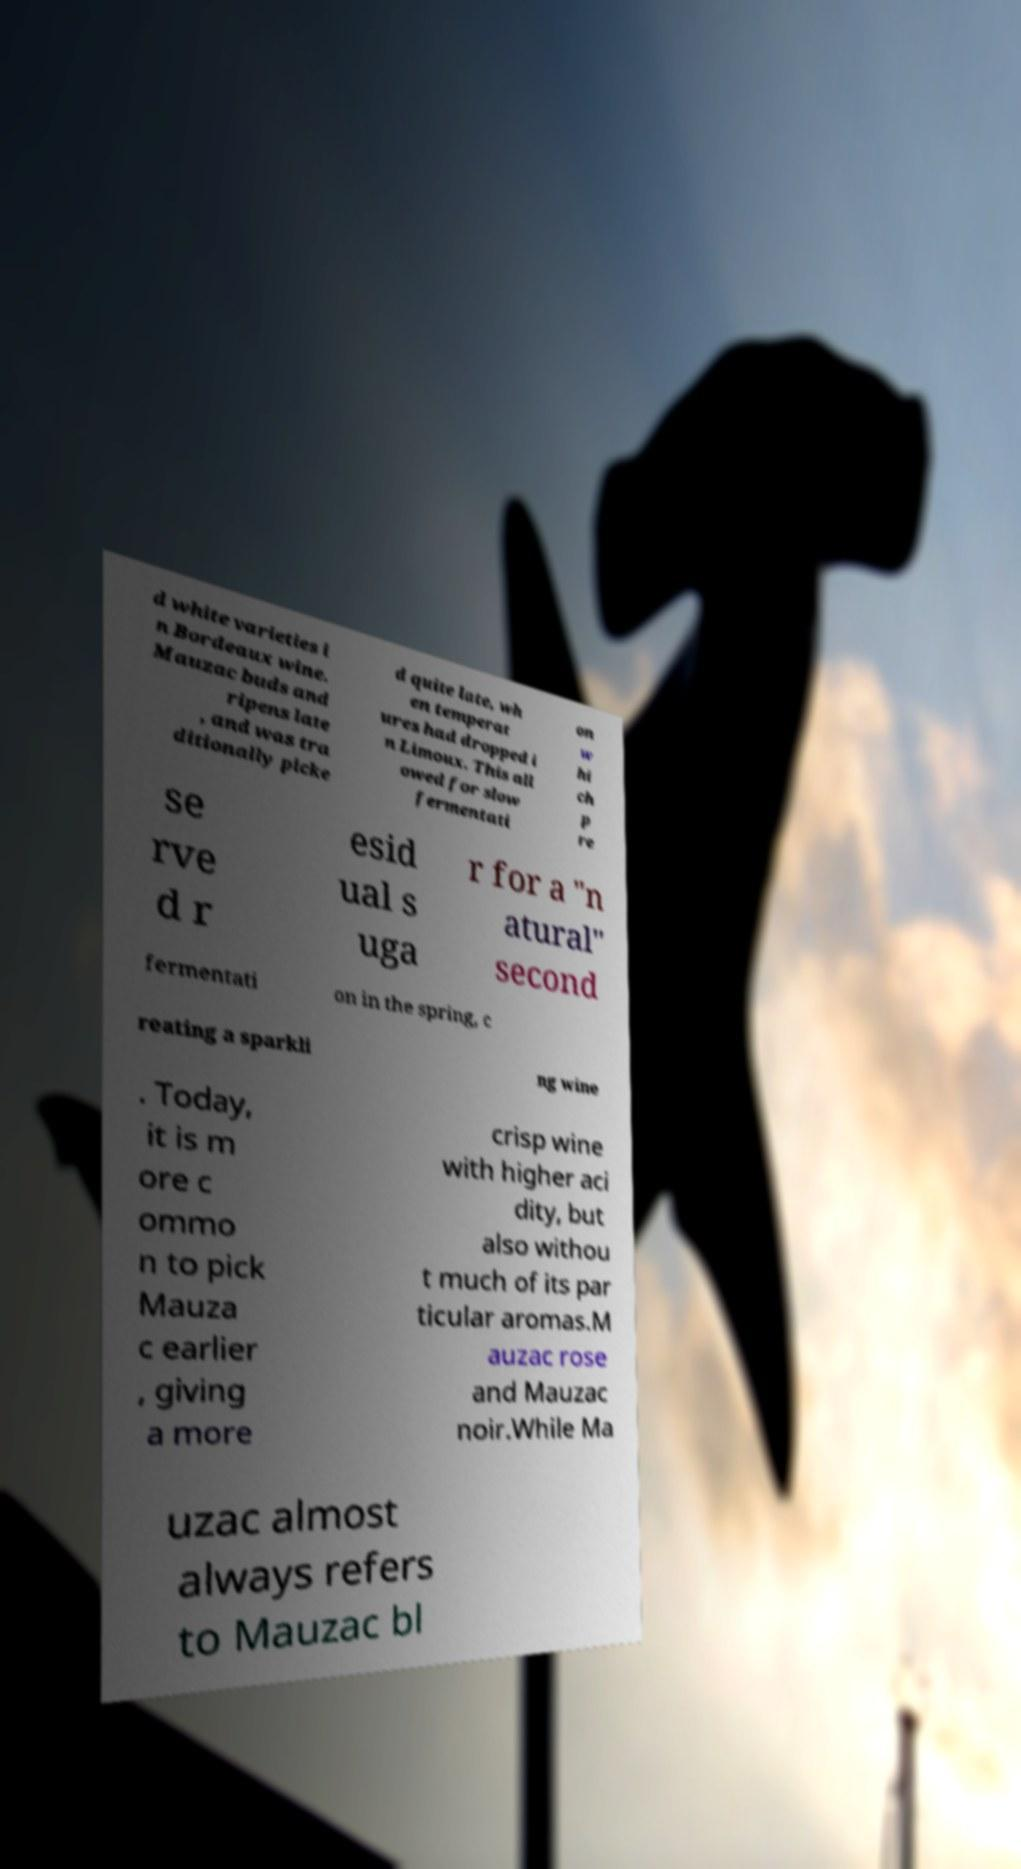What messages or text are displayed in this image? I need them in a readable, typed format. d white varieties i n Bordeaux wine. Mauzac buds and ripens late , and was tra ditionally picke d quite late, wh en temperat ures had dropped i n Limoux. This all owed for slow fermentati on w hi ch p re se rve d r esid ual s uga r for a "n atural" second fermentati on in the spring, c reating a sparkli ng wine . Today, it is m ore c ommo n to pick Mauza c earlier , giving a more crisp wine with higher aci dity, but also withou t much of its par ticular aromas.M auzac rose and Mauzac noir.While Ma uzac almost always refers to Mauzac bl 